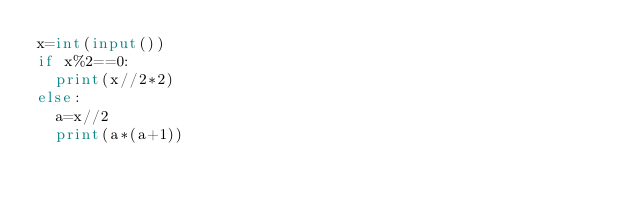Convert code to text. <code><loc_0><loc_0><loc_500><loc_500><_Python_>x=int(input())
if x%2==0:
  print(x//2*2)
else: 
  a=x//2
  print(a*(a+1))</code> 